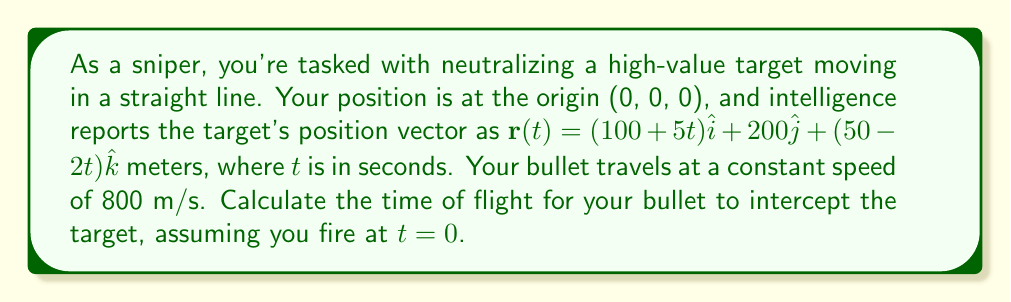Can you answer this question? To solve this problem, we need to find the time $t$ when the bullet's position equals the target's position. Let's approach this step-by-step:

1) The bullet's position vector can be expressed as:
   $\mathbf{b}(t) = 800t\hat{u}$
   where $\hat{u}$ is the unit vector in the direction of the bullet's path.

2) At the point of interception:
   $\mathbf{b}(t) = \mathbf{r}(t)$

3) We can write this as a system of equations:
   $800t u_x = 100 + 5t$
   $800t u_y = 200$
   $800t u_z = 50 - 2t$

4) We don't know $u_x$, $u_y$, and $u_z$, but we know that $\hat{u}$ is a unit vector, so:
   $u_x^2 + u_y^2 + u_z^2 = 1$

5) Squaring both sides of each equation in step 3 and adding them:
   $(800t)^2(u_x^2 + u_y^2 + u_z^2) = (100 + 5t)^2 + 200^2 + (50 - 2t)^2$

6) Substituting $u_x^2 + u_y^2 + u_z^2 = 1$:
   $(800t)^2 = (100 + 5t)^2 + 200^2 + (50 - 2t)^2$

7) Expanding:
   $640000t^2 = 10000 + 1000t + 25t^2 + 40000 + 2500 - 200t + 4t^2$

8) Simplifying:
   $639971t^2 - 1200t - 52500 = 0$

9) This is a quadratic equation in the form $at^2 + bt + c = 0$
   We can solve it using the quadratic formula: $t = \frac{-b \pm \sqrt{b^2 - 4ac}}{2a}$

10) Substituting our values:
    $t = \frac{1200 \pm \sqrt{1200^2 - 4(639971)(-52500)}}{2(639971)}$

11) Simplifying:
    $t \approx 0.2573$ or $t \approx -0.2575$

12) Since time can't be negative in this context, we take the positive solution.

Therefore, the time of flight for the bullet to intercept the target is approximately 0.2573 seconds.
Answer: 0.2573 seconds 